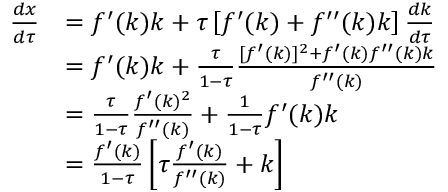<formula> <loc_0><loc_0><loc_500><loc_500>{ \begin{array} { r l } { { \frac { d x } { d \tau } } } & { = f ^ { \prime } ( k ) k + \tau \left [ f ^ { \prime } ( k ) + f ^ { \prime \prime } ( k ) k \right ] { \frac { d k } { d \tau } } } \\ & { = f ^ { \prime } ( k ) k + { \frac { \tau } { 1 - \tau } } { \frac { [ f ^ { \prime } ( k ) ] ^ { 2 } + f ^ { \prime } ( k ) f ^ { \prime \prime } ( k ) k } { f ^ { \prime \prime } ( k ) } } } \\ & { = { \frac { \tau } { 1 - \tau } } { \frac { f ^ { \prime } ( k ) ^ { 2 } } { f ^ { \prime \prime } ( k ) } } + { \frac { 1 } { 1 - \tau } } f ^ { \prime } ( k ) k } \\ & { = { \frac { f ^ { \prime } ( k ) } { 1 - \tau } } \left [ \tau { \frac { f ^ { \prime } ( k ) } { f ^ { \prime \prime } ( k ) } } + k \right ] } \end{array} }</formula> 